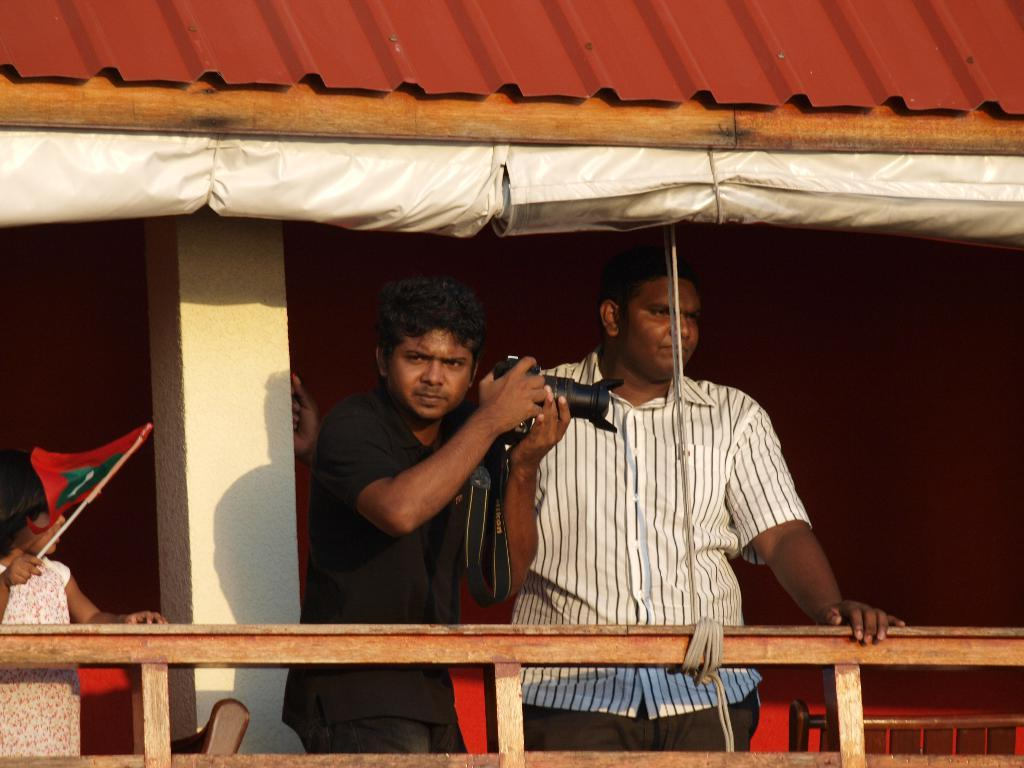What are the people in the image doing? The people in the image are standing. What object is the man holding in the image? The man is holding a camera. What object is the girl holding in the image? The girl is holding a flag. What part of a house can be seen in the image? The roof of a house is visible in the image. What type of furniture is present in the image? There are chairs on the side in the image. What type of silk is being used to make the agreement in the image? There is no agreement or silk present in the image. 